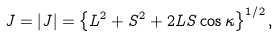<formula> <loc_0><loc_0><loc_500><loc_500>J = | { J } | = \left \{ L ^ { 2 } + S ^ { 2 } + 2 L S \cos \kappa \right \} ^ { 1 / 2 } ,</formula> 